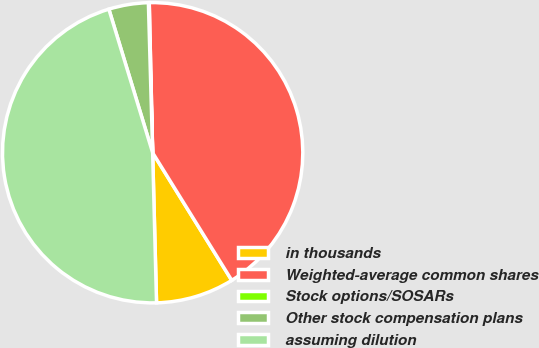Convert chart. <chart><loc_0><loc_0><loc_500><loc_500><pie_chart><fcel>in thousands<fcel>Weighted-average common shares<fcel>Stock options/SOSARs<fcel>Other stock compensation plans<fcel>assuming dilution<nl><fcel>8.42%<fcel>41.53%<fcel>0.09%<fcel>4.26%<fcel>45.7%<nl></chart> 